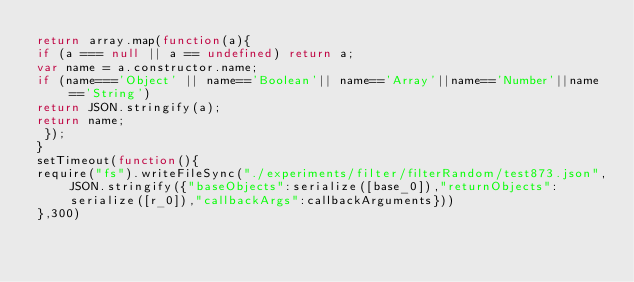Convert code to text. <code><loc_0><loc_0><loc_500><loc_500><_JavaScript_>return array.map(function(a){
if (a === null || a == undefined) return a;
var name = a.constructor.name;
if (name==='Object' || name=='Boolean'|| name=='Array'||name=='Number'||name=='String')
return JSON.stringify(a);
return name;
 });
}
setTimeout(function(){
require("fs").writeFileSync("./experiments/filter/filterRandom/test873.json",JSON.stringify({"baseObjects":serialize([base_0]),"returnObjects":serialize([r_0]),"callbackArgs":callbackArguments}))
},300)</code> 